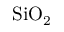Convert formula to latex. <formula><loc_0><loc_0><loc_500><loc_500>S i O _ { 2 }</formula> 